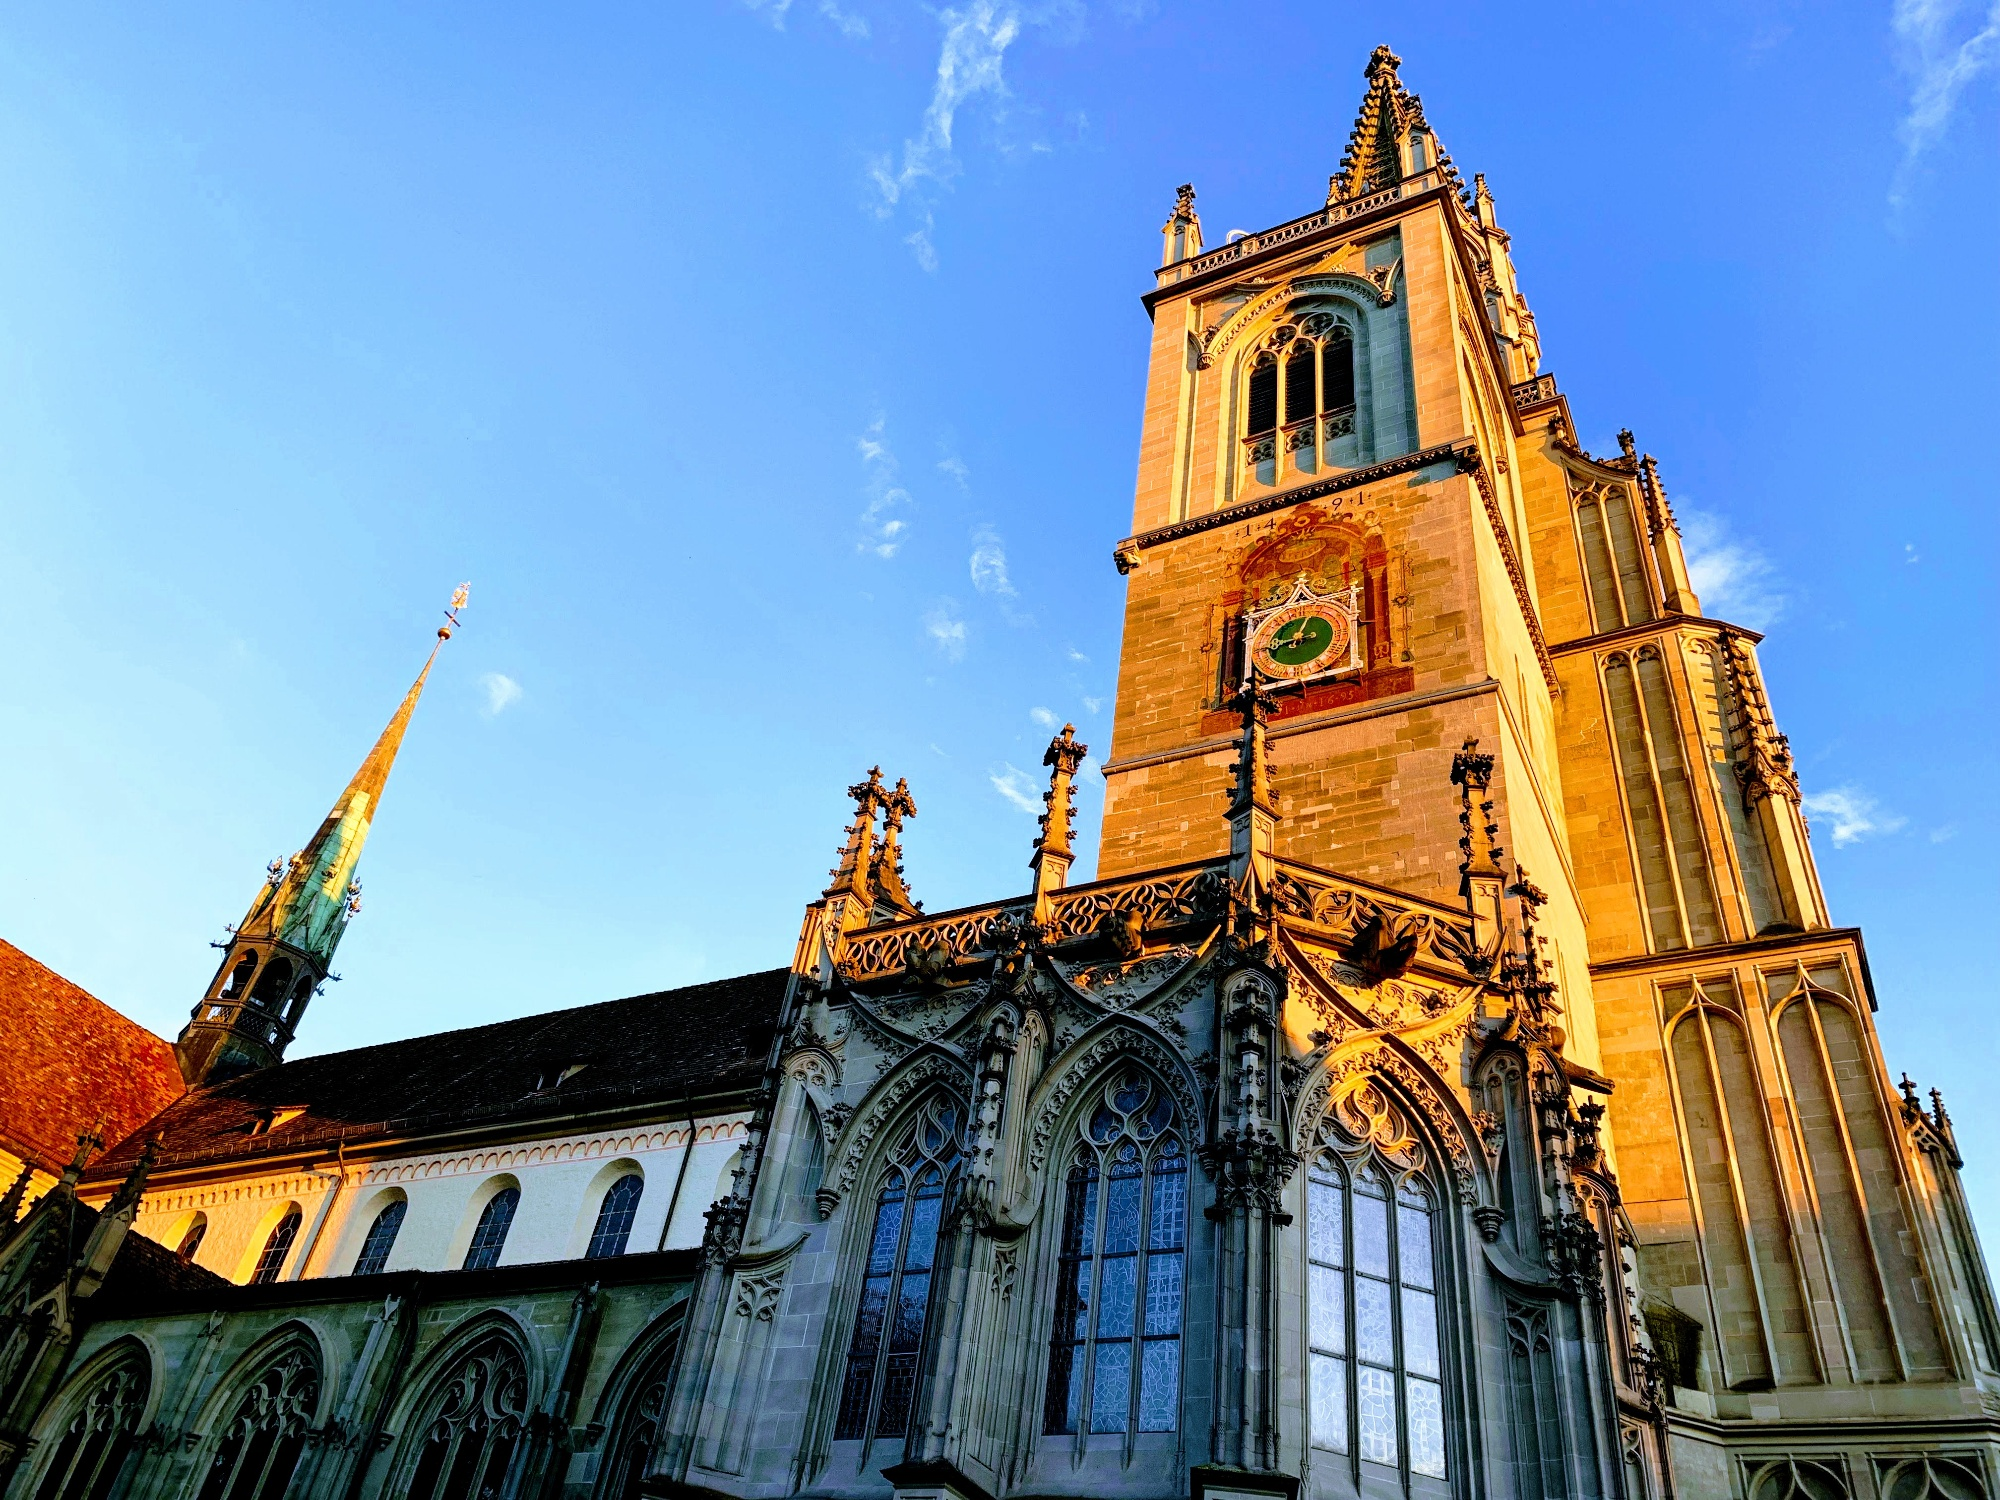Can you describe the main features of this image for me? The photograph beautifully captures the magnificence of Konstanz Minster, a notable historical cathedral in Konstanz, Germany. Taken from a low-angle perspective, the image emphasizes the cathedral's towering structure, reaching skywards with its elaborate Gothic design. The cathedral, constructed from light-colored stone, features a prominent clock face and a slender spire at the top of its main tower. The sunlight casts a golden hue over the building, highlighting the intricate stone carvings, decorative facades, and the architectural elegance of the flying buttresses. Konstanz Minster, dating back to the 7th century, holds significant historical value, especially for its role in the Council of Constance. The interplay of light and shadow adds a dramatic effect, while the vibrant blue sky serves as a perfect backdrop, enhancing the cathedral's timeless beauty and cultural importance. 